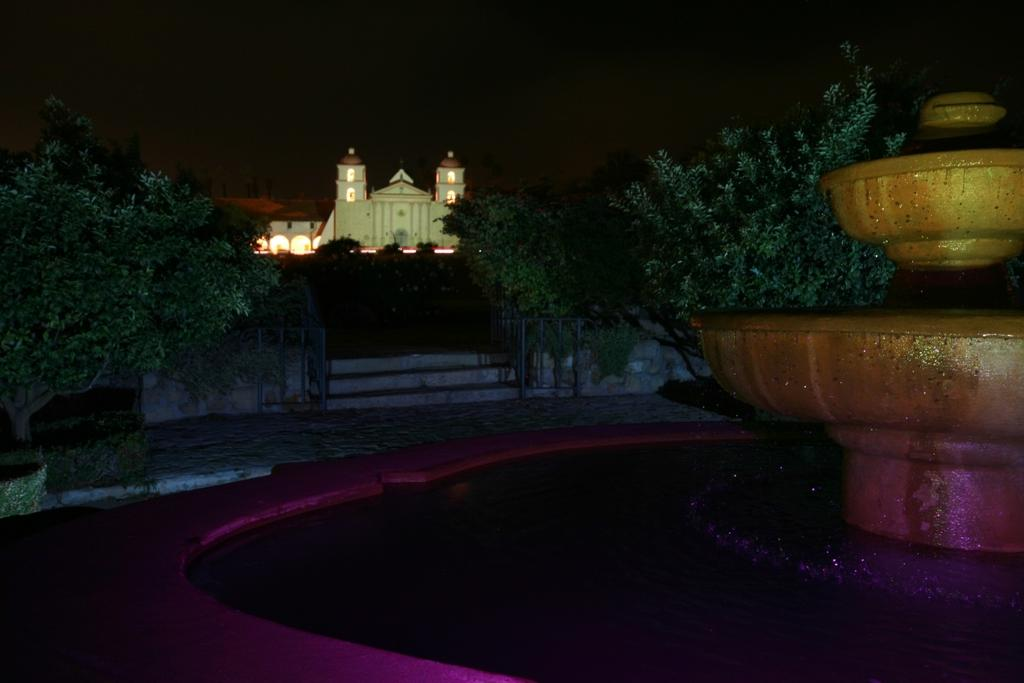What is the lighting condition in the image? The image was taken in the dark. What is the main subject in the image? There is a fountain in the image. What can be seen in the background of the image? There is a building and trees in the background of the image. Are there any architectural features visible in the image? Yes, there are stairs visible in the image. What type of mailbox can be seen near the fountain in the image? There is no mailbox present in the image. What is the zinc content of the water in the fountain? There is no information about the zinc content of the water in the image. 